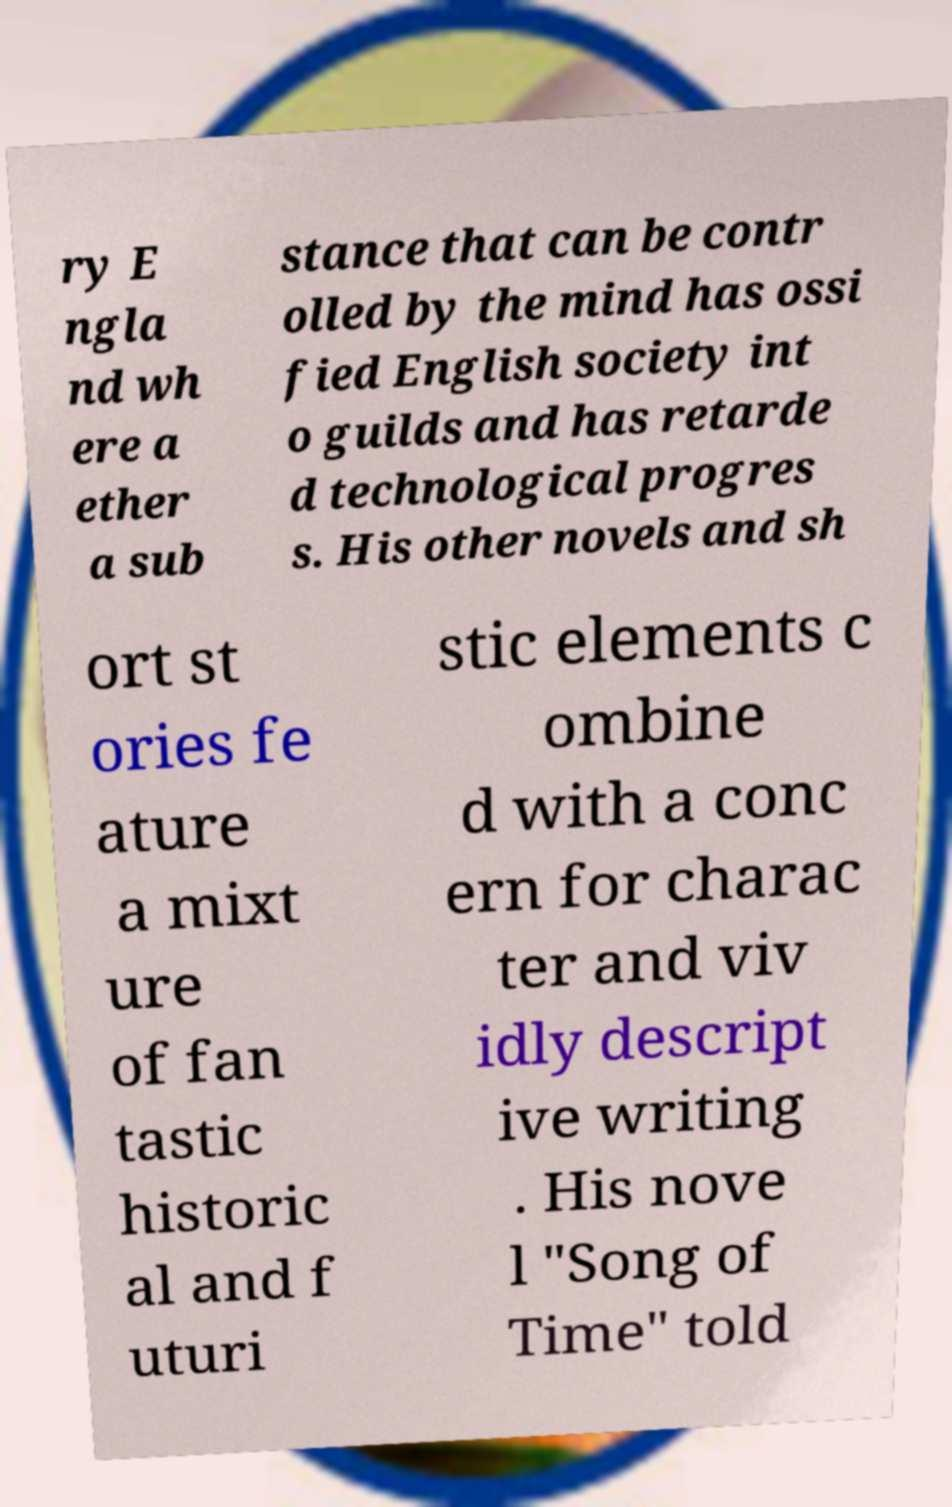Please identify and transcribe the text found in this image. ry E ngla nd wh ere a ether a sub stance that can be contr olled by the mind has ossi fied English society int o guilds and has retarde d technological progres s. His other novels and sh ort st ories fe ature a mixt ure of fan tastic historic al and f uturi stic elements c ombine d with a conc ern for charac ter and viv idly descript ive writing . His nove l "Song of Time" told 